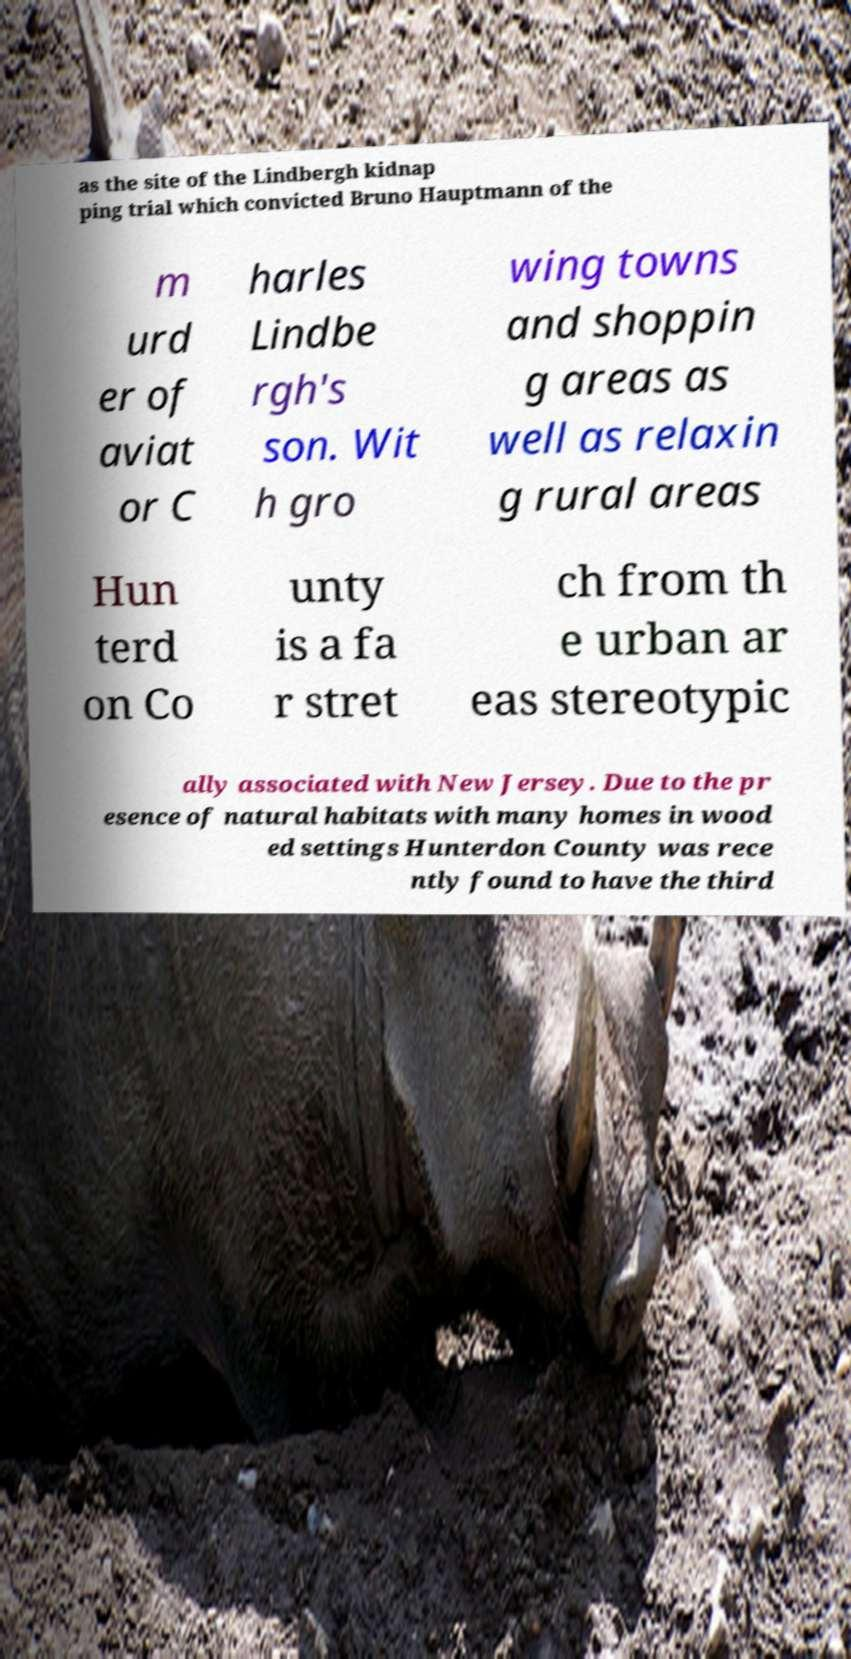Please identify and transcribe the text found in this image. as the site of the Lindbergh kidnap ping trial which convicted Bruno Hauptmann of the m urd er of aviat or C harles Lindbe rgh's son. Wit h gro wing towns and shoppin g areas as well as relaxin g rural areas Hun terd on Co unty is a fa r stret ch from th e urban ar eas stereotypic ally associated with New Jersey. Due to the pr esence of natural habitats with many homes in wood ed settings Hunterdon County was rece ntly found to have the third 